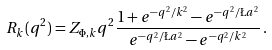Convert formula to latex. <formula><loc_0><loc_0><loc_500><loc_500>R _ { k } ( q ^ { 2 } ) = Z _ { \Phi , k } q ^ { 2 } \frac { 1 + e ^ { - q ^ { 2 } / k ^ { 2 } } - e ^ { - q ^ { 2 } / \L a ^ { 2 } } } { e ^ { - q ^ { 2 } / \L a ^ { 2 } } - e ^ { - q ^ { 2 } / k ^ { 2 } } } \, .</formula> 